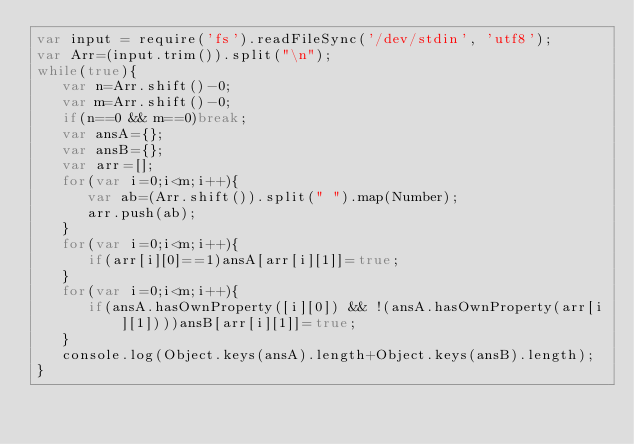<code> <loc_0><loc_0><loc_500><loc_500><_JavaScript_>var input = require('fs').readFileSync('/dev/stdin', 'utf8');
var Arr=(input.trim()).split("\n");
while(true){
   var n=Arr.shift()-0;
   var m=Arr.shift()-0;
   if(n==0 && m==0)break;
   var ansA={};
   var ansB={};
   var arr=[];
   for(var i=0;i<m;i++){
      var ab=(Arr.shift()).split(" ").map(Number);
      arr.push(ab);
   }
   for(var i=0;i<m;i++){
      if(arr[i][0]==1)ansA[arr[i][1]]=true;
   }
   for(var i=0;i<m;i++){
      if(ansA.hasOwnProperty([i][0]) && !(ansA.hasOwnProperty(arr[i][1])))ansB[arr[i][1]]=true;
   }
   console.log(Object.keys(ansA).length+Object.keys(ansB).length);
}</code> 